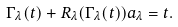<formula> <loc_0><loc_0><loc_500><loc_500>\Gamma _ { \lambda } ( t ) + R _ { \lambda } ( \Gamma _ { \lambda } ( t ) ) a _ { \lambda } = t .</formula> 